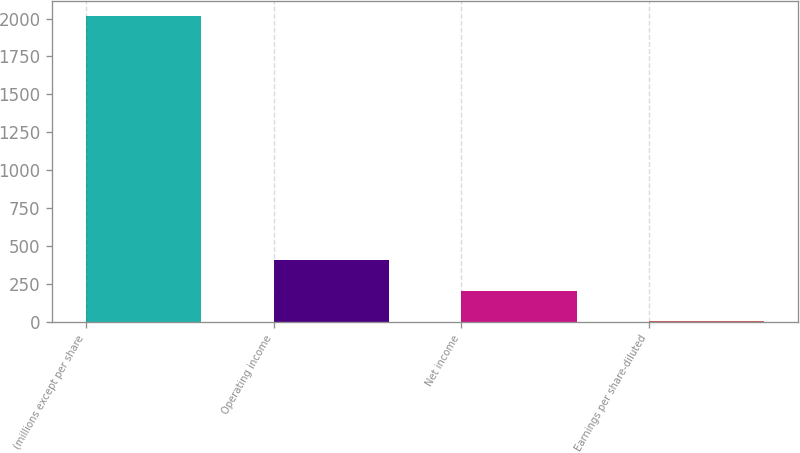Convert chart. <chart><loc_0><loc_0><loc_500><loc_500><bar_chart><fcel>(millions except per share<fcel>Operating income<fcel>Net income<fcel>Earnings per share-diluted<nl><fcel>2017<fcel>403.84<fcel>202.19<fcel>0.54<nl></chart> 